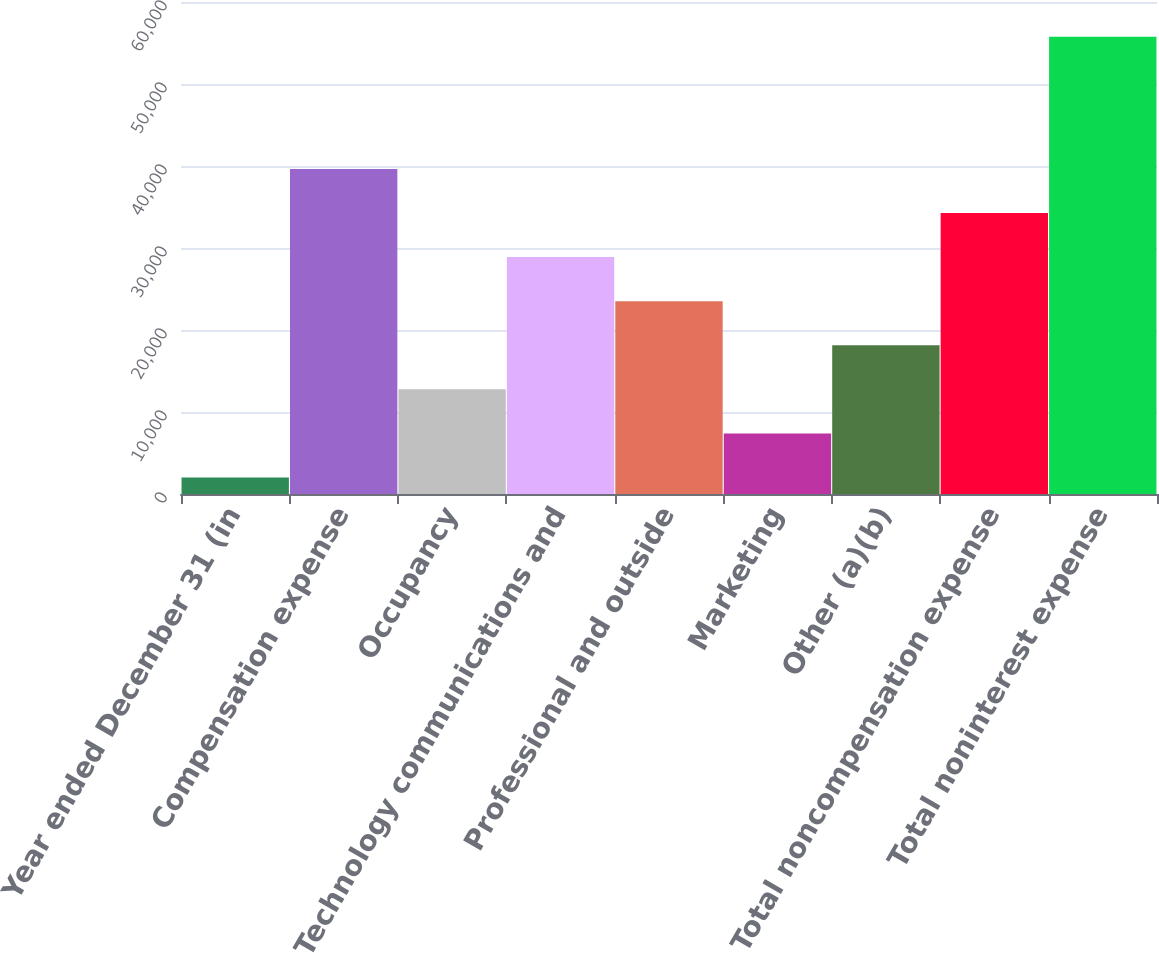<chart> <loc_0><loc_0><loc_500><loc_500><bar_chart><fcel>Year ended December 31 (in<fcel>Compensation expense<fcel>Occupancy<fcel>Technology communications and<fcel>Professional and outside<fcel>Marketing<fcel>Other (a)(b)<fcel>Total noncompensation expense<fcel>Total noninterest expense<nl><fcel>2016<fcel>39644.5<fcel>12767<fcel>28893.5<fcel>23518<fcel>7391.5<fcel>18142.5<fcel>34269<fcel>55771<nl></chart> 